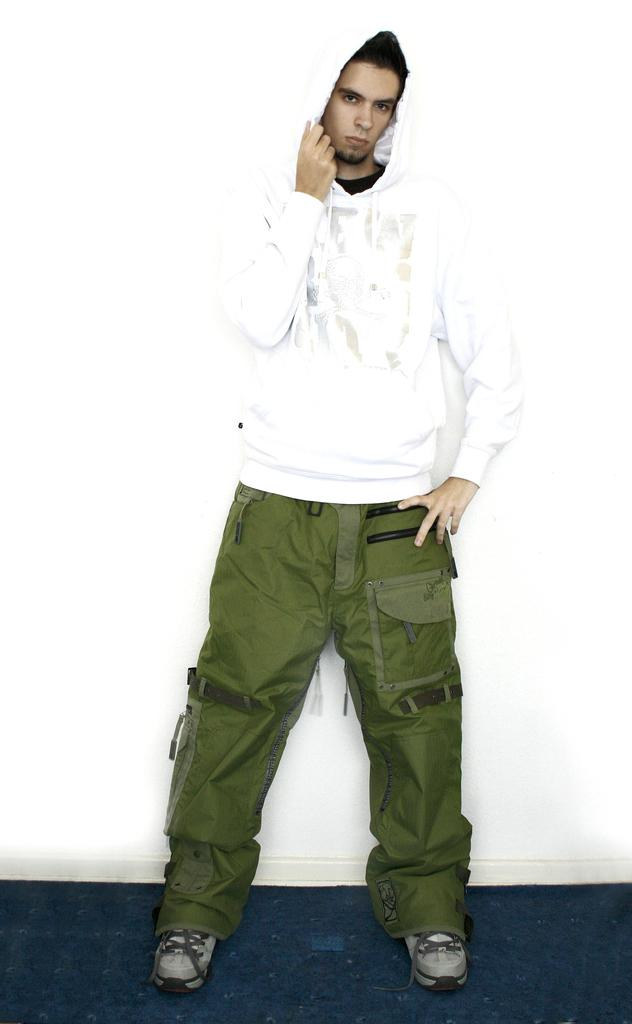Who is present in the image? There is a man in the image. What can be seen behind the man in the image? The background of the image is white. How many ants are crawling on the man's face in the image? There are no ants present in the image. What type of bean is being used as a prop in the image? There is no bean present in the image. 